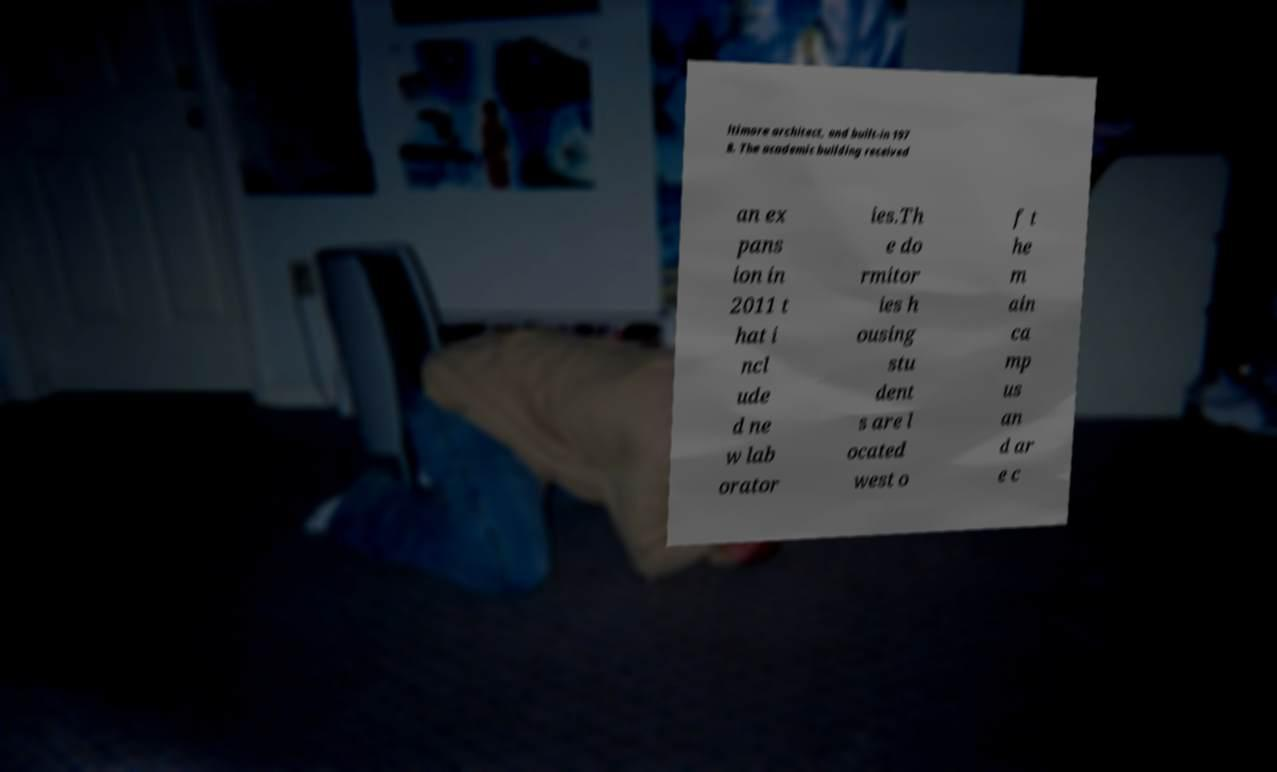What messages or text are displayed in this image? I need them in a readable, typed format. ltimore architect, and built-in 197 8. The academic building received an ex pans ion in 2011 t hat i ncl ude d ne w lab orator ies.Th e do rmitor ies h ousing stu dent s are l ocated west o f t he m ain ca mp us an d ar e c 